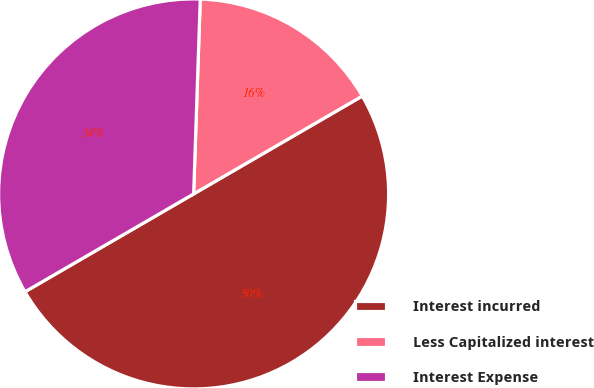<chart> <loc_0><loc_0><loc_500><loc_500><pie_chart><fcel>Interest incurred<fcel>Less Capitalized interest<fcel>Interest Expense<nl><fcel>50.0%<fcel>16.09%<fcel>33.91%<nl></chart> 